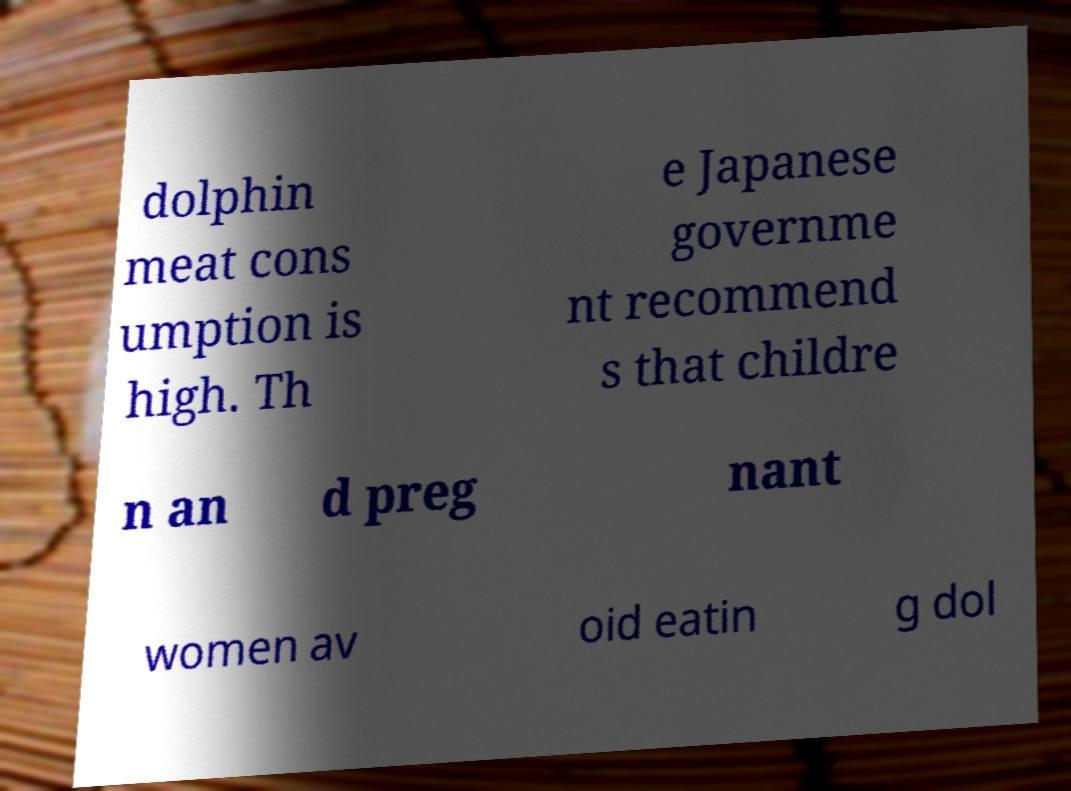Could you assist in decoding the text presented in this image and type it out clearly? dolphin meat cons umption is high. Th e Japanese governme nt recommend s that childre n an d preg nant women av oid eatin g dol 